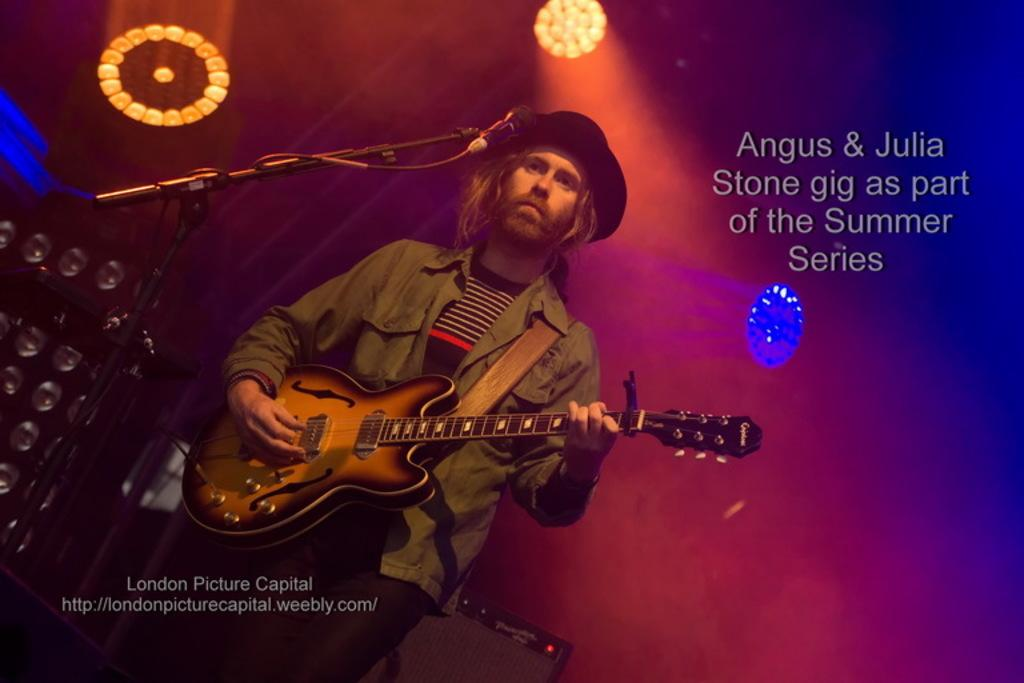What is the main subject of the image? There is a man in the image. What is the man doing in the image? The man is standing in the image. What is the man wearing in the image? The man is wearing a jacket and a hat in the image. What object is the man holding in the image? The man is holding a guitar in the image. What other object is present in the image? There is a microphone in the image. What can be seen in the background of the image? There are lights visible in the image. What day of the week is it in the image? The day of the week is not mentioned or visible in the image. Is there a roof visible in the image? No, there is no roof visible in the image. 